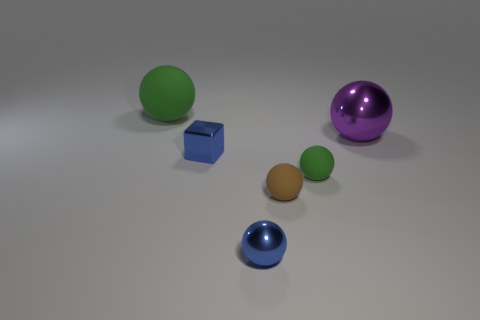There is a small thing that is the same color as the tiny block; what is its shape?
Your answer should be compact. Sphere. There is a metal object that is the same color as the tiny metallic cube; what is its size?
Your answer should be compact. Small. Do the purple sphere and the brown matte sphere have the same size?
Your answer should be compact. No. What number of blocks are either large things or tiny green rubber objects?
Offer a very short reply. 0. There is a rubber sphere in front of the green matte sphere that is in front of the big metallic ball; what color is it?
Offer a terse response. Brown. Are there fewer blue metallic cubes that are in front of the big purple metal sphere than spheres that are in front of the brown sphere?
Make the answer very short. No. Is the size of the purple shiny object the same as the green object left of the small green rubber sphere?
Offer a terse response. Yes. What shape is the shiny object that is both to the right of the tiny blue block and in front of the purple ball?
Ensure brevity in your answer.  Sphere. What is the size of the blue thing that is the same material as the blue block?
Ensure brevity in your answer.  Small. There is a small ball in front of the tiny brown rubber ball; what number of tiny rubber spheres are on the left side of it?
Your answer should be compact. 0. 